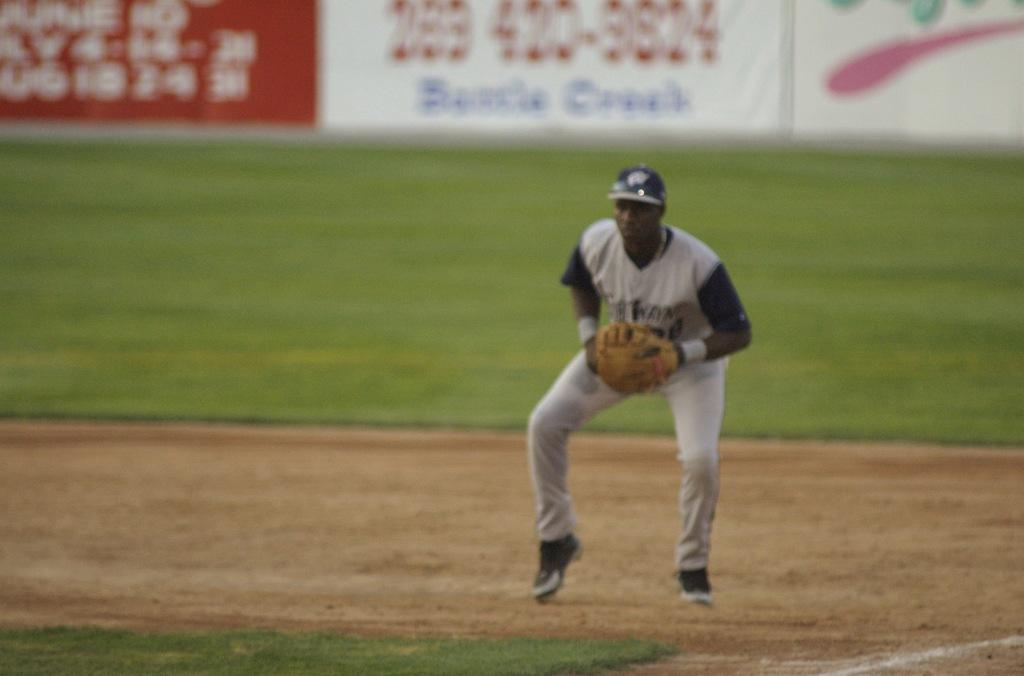What is the man in the image wearing on his upper body? The man is wearing a T-shirt in the image. What type of headwear is the man wearing? The man is wearing a cap in the image. What type of clothing is the man wearing on his lower body? The man is wearing trousers in the image. What type of footwear is the man wearing? The man is wearing shoes in the image. What type of hand covering is the man wearing? The man is wearing gloves in the image. What is the setting of the image? The image appears to be set on a ground. What can be seen in the background of the image? There are hoardings visible in the background of the image. What type of sack is the man carrying in the image? There is no sack visible in the image; the man is not carrying anything. What type of office furniture can be seen in the image? There is no office furniture present in the image; it is set outdoors. 